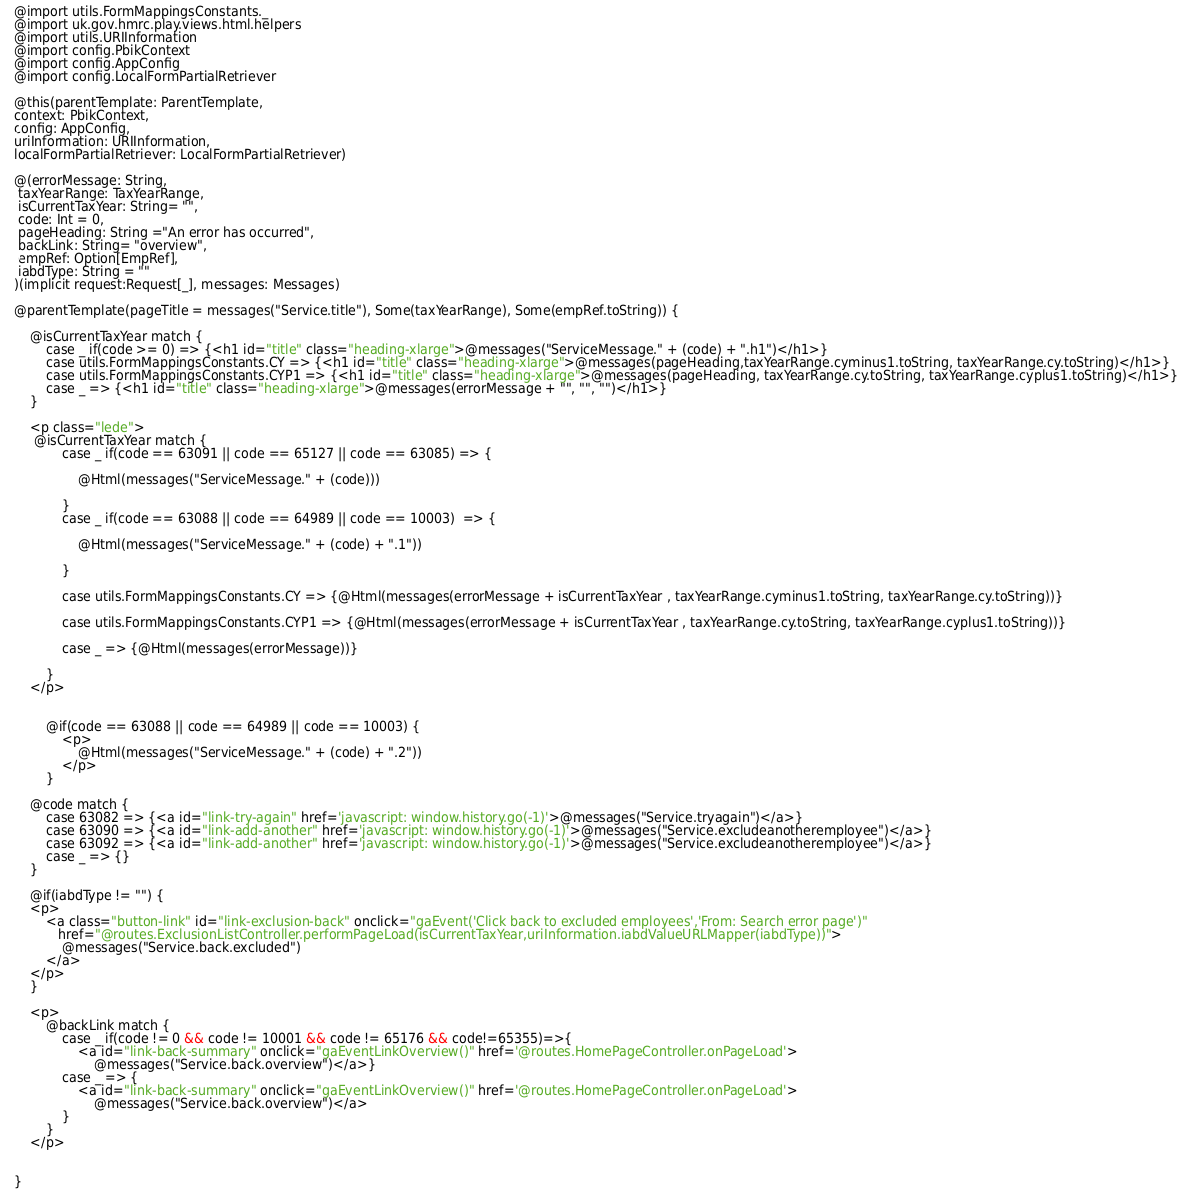Convert code to text. <code><loc_0><loc_0><loc_500><loc_500><_HTML_>
@import utils.FormMappingsConstants._
@import uk.gov.hmrc.play.views.html.helpers
@import utils.URIInformation
@import config.PbikContext
@import config.AppConfig
@import config.LocalFormPartialRetriever

@this(parentTemplate: ParentTemplate,
context: PbikContext,
config: AppConfig,
uriInformation: URIInformation,
localFormPartialRetriever: LocalFormPartialRetriever)

@(errorMessage: String,
 taxYearRange: TaxYearRange,
 isCurrentTaxYear: String= "",
 code: Int = 0,
 pageHeading: String ="An error has occurred",
 backLink: String= "overview",
 empRef: Option[EmpRef],
 iabdType: String = ""
)(implicit request:Request[_], messages: Messages)

@parentTemplate(pageTitle = messages("Service.title"), Some(taxYearRange), Some(empRef.toString)) {

    @isCurrentTaxYear match {
        case _ if(code >= 0) => {<h1 id="title" class="heading-xlarge">@messages("ServiceMessage." + (code) + ".h1")</h1>}
        case utils.FormMappingsConstants.CY => {<h1 id="title" class="heading-xlarge">@messages(pageHeading,taxYearRange.cyminus1.toString, taxYearRange.cy.toString)</h1>}
        case utils.FormMappingsConstants.CYP1 => {<h1 id="title" class="heading-xlarge">@messages(pageHeading, taxYearRange.cy.toString, taxYearRange.cyplus1.toString)</h1>}
        case _ => {<h1 id="title" class="heading-xlarge">@messages(errorMessage + "", "", "")</h1>}
    }

    <p class="lede">
     @isCurrentTaxYear match {
            case _ if(code == 63091 || code == 65127 || code == 63085) => {

                @Html(messages("ServiceMessage." + (code)))

            }
            case _ if(code == 63088 || code == 64989 || code == 10003)  => {

                @Html(messages("ServiceMessage." + (code) + ".1"))

            }

            case utils.FormMappingsConstants.CY => {@Html(messages(errorMessage + isCurrentTaxYear , taxYearRange.cyminus1.toString, taxYearRange.cy.toString))}

            case utils.FormMappingsConstants.CYP1 => {@Html(messages(errorMessage + isCurrentTaxYear , taxYearRange.cy.toString, taxYearRange.cyplus1.toString))}

            case _ => {@Html(messages(errorMessage))}

        }
    </p>


        @if(code == 63088 || code == 64989 || code == 10003) {
            <p>
                @Html(messages("ServiceMessage." + (code) + ".2"))
            </p>
        }

    @code match {
        case 63082 => {<a id="link-try-again" href='javascript: window.history.go(-1)'>@messages("Service.tryagain")</a>}
        case 63090 => {<a id="link-add-another" href='javascript: window.history.go(-1)'>@messages("Service.excludeanotheremployee")</a>}
        case 63092 => {<a id="link-add-another" href='javascript: window.history.go(-1)'>@messages("Service.excludeanotheremployee")</a>}
        case _ => {}
    }

    @if(iabdType != "") {
    <p>
        <a class="button-link" id="link-exclusion-back" onclick="gaEvent('Click back to excluded employees','From: Search error page')"
           href="@routes.ExclusionListController.performPageLoad(isCurrentTaxYear,uriInformation.iabdValueURLMapper(iabdType))">
            @messages("Service.back.excluded")
        </a>
    </p>
    }

    <p>
        @backLink match {
            case _ if(code != 0 && code != 10001 && code != 65176 && code!=65355)=>{
                <a id="link-back-summary" onclick="gaEventLinkOverview()" href='@routes.HomePageController.onPageLoad'>
                    @messages("Service.back.overview")</a>}
            case _ => {
                <a id="link-back-summary" onclick="gaEventLinkOverview()" href='@routes.HomePageController.onPageLoad'>
                    @messages("Service.back.overview")</a>
            }
        }
    </p>


}
</code> 